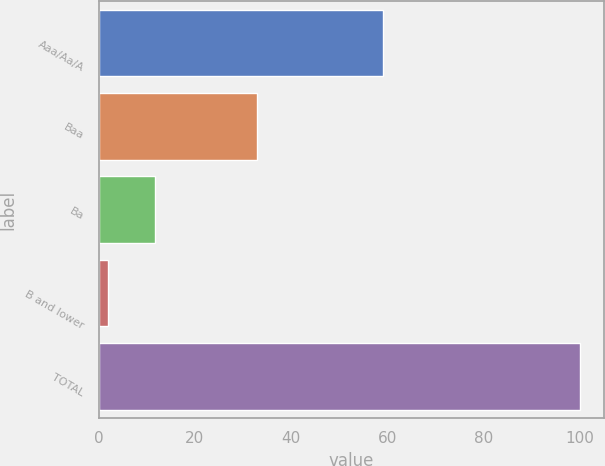Convert chart to OTSL. <chart><loc_0><loc_0><loc_500><loc_500><bar_chart><fcel>Aaa/Aa/A<fcel>Baa<fcel>Ba<fcel>B and lower<fcel>TOTAL<nl><fcel>59<fcel>33<fcel>11.8<fcel>2<fcel>100<nl></chart> 